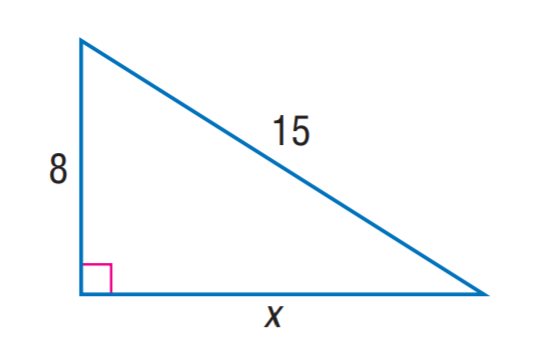Answer the mathemtical geometry problem and directly provide the correct option letter.
Question: Find x. Round to the nearest tenth.
Choices: A: 11.7 B: 12.7 C: 13.3 D: 13.7 B 